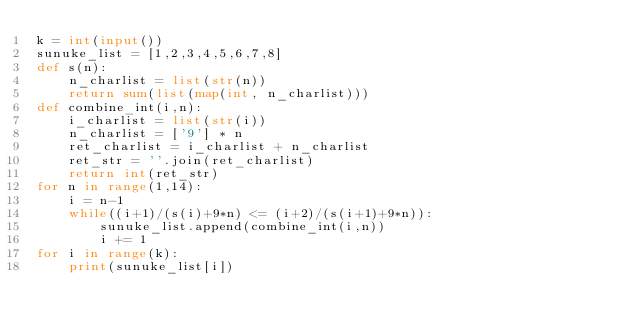Convert code to text. <code><loc_0><loc_0><loc_500><loc_500><_Python_>k = int(input())
sunuke_list = [1,2,3,4,5,6,7,8]
def s(n):
    n_charlist = list(str(n))
    return sum(list(map(int, n_charlist)))
def combine_int(i,n):
    i_charlist = list(str(i))
    n_charlist = ['9'] * n
    ret_charlist = i_charlist + n_charlist
    ret_str = ''.join(ret_charlist)
    return int(ret_str)
for n in range(1,14):
    i = n-1
    while((i+1)/(s(i)+9*n) <= (i+2)/(s(i+1)+9*n)):
        sunuke_list.append(combine_int(i,n))
        i += 1
for i in range(k):
    print(sunuke_list[i])
</code> 